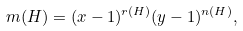Convert formula to latex. <formula><loc_0><loc_0><loc_500><loc_500>m ( H ) & = ( x - 1 ) ^ { r ( H ) } ( y - 1 ) ^ { n ( H ) } ,</formula> 